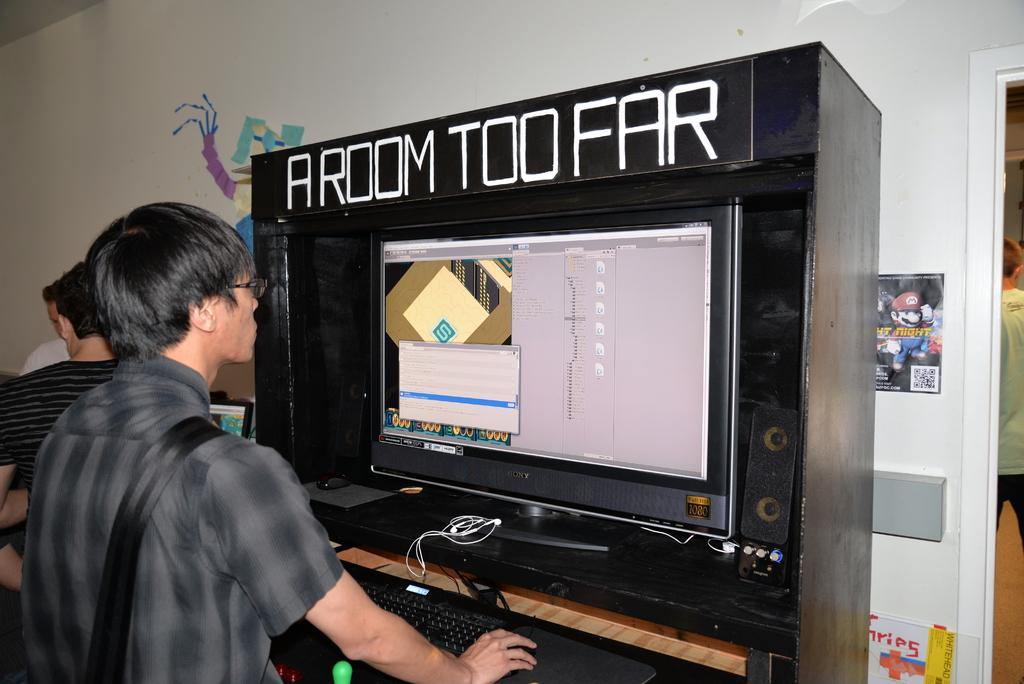What sentence is in big white letters over the computer?
Keep it short and to the point. A room too far. 